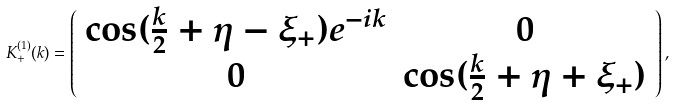<formula> <loc_0><loc_0><loc_500><loc_500>K ^ { ( 1 ) } _ { + } ( k ) = \left ( \begin{array} { c c } \cos ( \frac { k } { 2 } + \eta - \xi _ { + } ) e ^ { - i k } & 0 \\ 0 & \cos ( \frac { k } { 2 } + \eta + \xi _ { + } ) \end{array} \right ) ,</formula> 